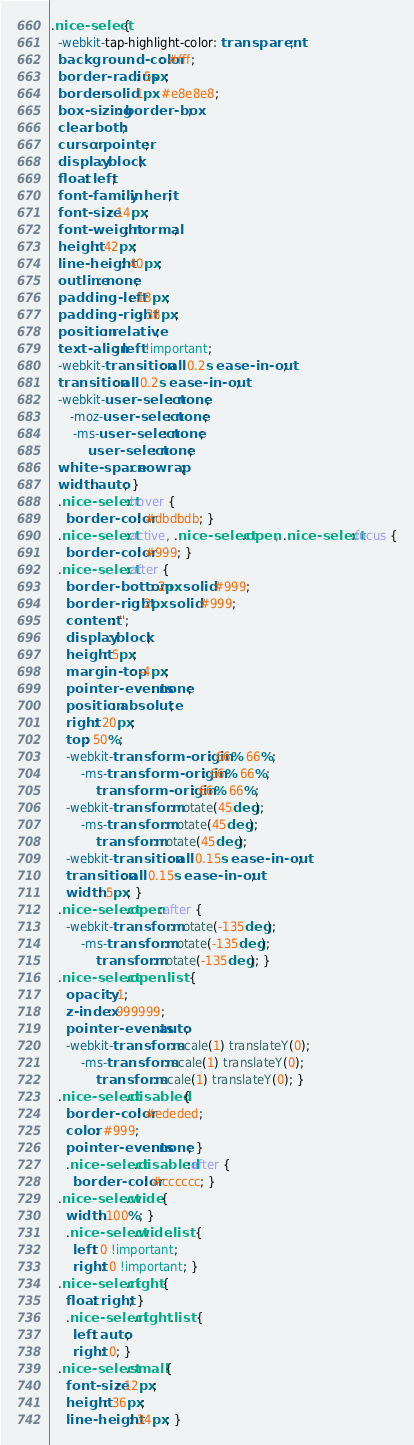Convert code to text. <code><loc_0><loc_0><loc_500><loc_500><_CSS_>.nice-select {
  -webkit-tap-highlight-color: transparent;
  background-color: #fff;
  border-radius: 5px;
  border: solid 1px #e8e8e8;
  box-sizing: border-box;
  clear: both;
  cursor: pointer;
  display: block;
  float: left;
  font-family: inherit;
  font-size: 14px;
  font-weight: normal;
  height: 42px;
  line-height: 40px;
  outline: none;
  padding-left: 18px;
  padding-right: 38px;
  position: relative;
  text-align: left !important;
  -webkit-transition: all 0.2s ease-in-out;
  transition: all 0.2s ease-in-out;
  -webkit-user-select: none;
     -moz-user-select: none;
      -ms-user-select: none;
          user-select: none;
  white-space: nowrap;
  width: auto; }
  .nice-select:hover {
    border-color: #dbdbdb; }
  .nice-select:active, .nice-select.open, .nice-select:focus {
    border-color: #999; }
  .nice-select:after {
    border-bottom: 2px solid #999;
    border-right: 2px solid #999;
    content: '';
    display: block;
    height: 5px;
    margin-top: -4px;
    pointer-events: none;
    position: absolute;
    right: 20px;
    top: 50%;
    -webkit-transform-origin: 66% 66%;
        -ms-transform-origin: 66% 66%;
            transform-origin: 66% 66%;
    -webkit-transform: rotate(45deg);
        -ms-transform: rotate(45deg);
            transform: rotate(45deg);
    -webkit-transition: all 0.15s ease-in-out;
    transition: all 0.15s ease-in-out;
    width: 5px; }
  .nice-select.open:after {
    -webkit-transform: rotate(-135deg);
        -ms-transform: rotate(-135deg);
            transform: rotate(-135deg); }
  .nice-select.open .list {
    opacity: 1;
    z-index: 999999;
    pointer-events: auto;
    -webkit-transform: scale(1) translateY(0);
        -ms-transform: scale(1) translateY(0);
            transform: scale(1) translateY(0); }
  .nice-select.disabled {
    border-color: #ededed;
    color: #999;
    pointer-events: none; }
    .nice-select.disabled:after {
      border-color: #cccccc; }
  .nice-select.wide {
    width: 100%; }
    .nice-select.wide .list {
      left: 0 !important;
      right: 0 !important; }
  .nice-select.right {
    float: right; }
    .nice-select.right .list {
      left: auto;
      right: 0; }
  .nice-select.small {
    font-size: 12px;
    height: 36px;
    line-height: 34px; }</code> 